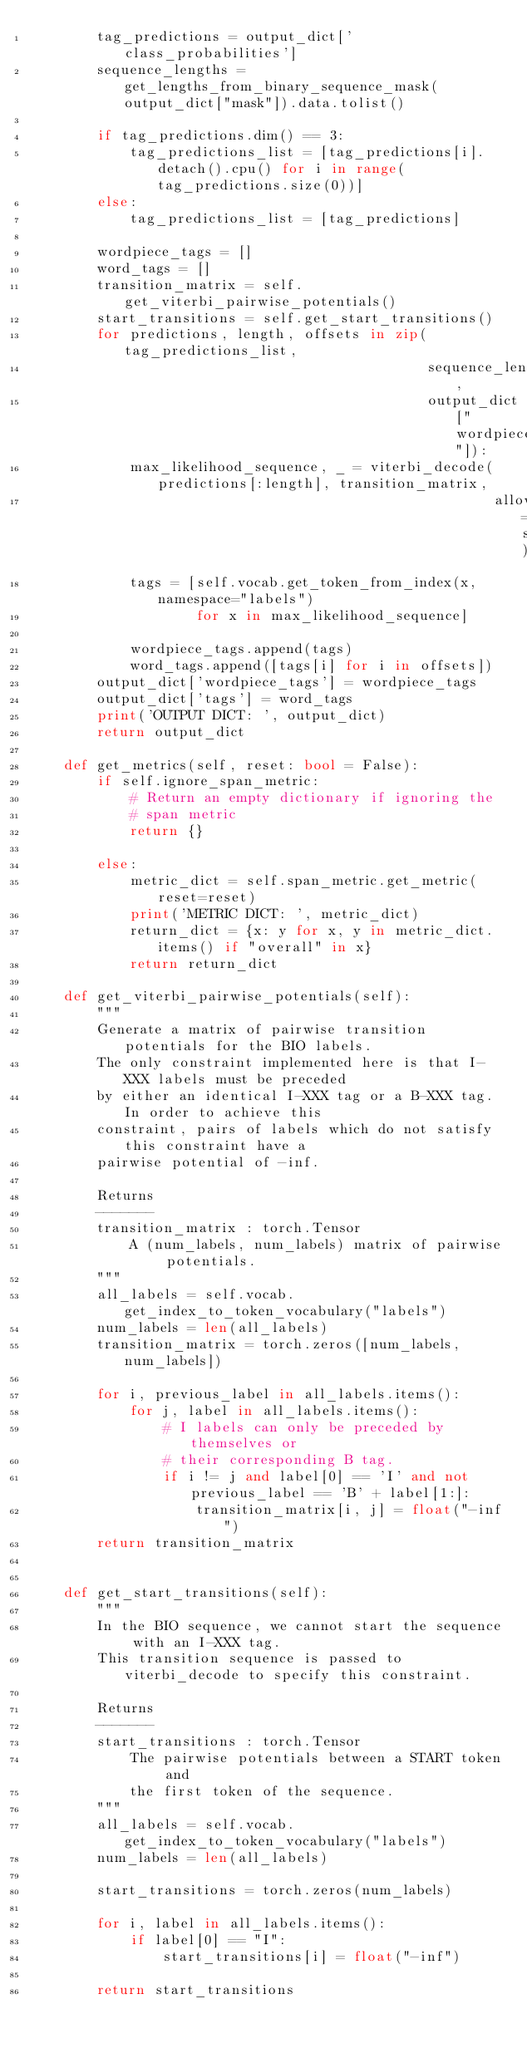Convert code to text. <code><loc_0><loc_0><loc_500><loc_500><_Python_>        tag_predictions = output_dict['class_probabilities']
        sequence_lengths = get_lengths_from_binary_sequence_mask(output_dict["mask"]).data.tolist()

        if tag_predictions.dim() == 3:
            tag_predictions_list = [tag_predictions[i].detach().cpu() for i in range(tag_predictions.size(0))]
        else:
            tag_predictions_list = [tag_predictions]
        
        wordpiece_tags = []
        word_tags = []
        transition_matrix = self.get_viterbi_pairwise_potentials()
        start_transitions = self.get_start_transitions()
        for predictions, length, offsets in zip(tag_predictions_list,
                                                sequence_lengths,
                                                output_dict["wordpiece_offsets"]):
            max_likelihood_sequence, _ = viterbi_decode(predictions[:length], transition_matrix,
                                                        allowed_start_transitions=start_transitions)
            tags = [self.vocab.get_token_from_index(x, namespace="labels")
                    for x in max_likelihood_sequence]

            wordpiece_tags.append(tags)
            word_tags.append([tags[i] for i in offsets])
        output_dict['wordpiece_tags'] = wordpiece_tags
        output_dict['tags'] = word_tags
        print('OUTPUT DICT: ', output_dict)
        return output_dict

    def get_metrics(self, reset: bool = False):
        if self.ignore_span_metric:
            # Return an empty dictionary if ignoring the
            # span metric
            return {}

        else:
            metric_dict = self.span_metric.get_metric(reset=reset)
            print('METRIC DICT: ', metric_dict)
            return_dict = {x: y for x, y in metric_dict.items() if "overall" in x}
            return return_dict
            
    def get_viterbi_pairwise_potentials(self):
        """
        Generate a matrix of pairwise transition potentials for the BIO labels.
        The only constraint implemented here is that I-XXX labels must be preceded
        by either an identical I-XXX tag or a B-XXX tag. In order to achieve this
        constraint, pairs of labels which do not satisfy this constraint have a
        pairwise potential of -inf.

        Returns
        -------
        transition_matrix : torch.Tensor
            A (num_labels, num_labels) matrix of pairwise potentials.
        """
        all_labels = self.vocab.get_index_to_token_vocabulary("labels")
        num_labels = len(all_labels)
        transition_matrix = torch.zeros([num_labels, num_labels])

        for i, previous_label in all_labels.items():
            for j, label in all_labels.items():
                # I labels can only be preceded by themselves or
                # their corresponding B tag.
                if i != j and label[0] == 'I' and not previous_label == 'B' + label[1:]:
                    transition_matrix[i, j] = float("-inf")
        return transition_matrix


    def get_start_transitions(self):
        """
        In the BIO sequence, we cannot start the sequence with an I-XXX tag.
        This transition sequence is passed to viterbi_decode to specify this constraint.

        Returns
        -------
        start_transitions : torch.Tensor
            The pairwise potentials between a START token and
            the first token of the sequence.
        """
        all_labels = self.vocab.get_index_to_token_vocabulary("labels")
        num_labels = len(all_labels)

        start_transitions = torch.zeros(num_labels)

        for i, label in all_labels.items():
            if label[0] == "I":
                start_transitions[i] = float("-inf")

        return start_transitions
</code> 